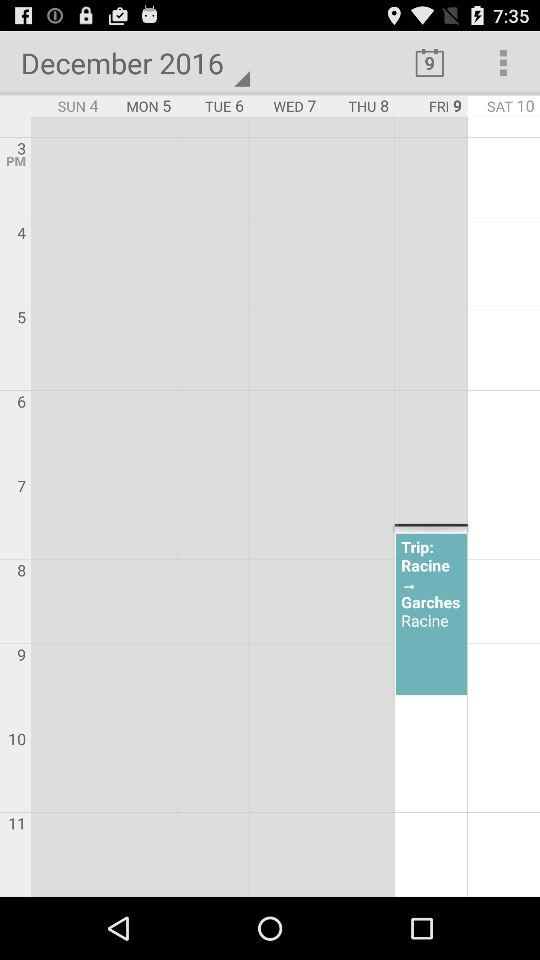What is the date displayed on the screen? The displayed date is Friday, December 9, 2016. 